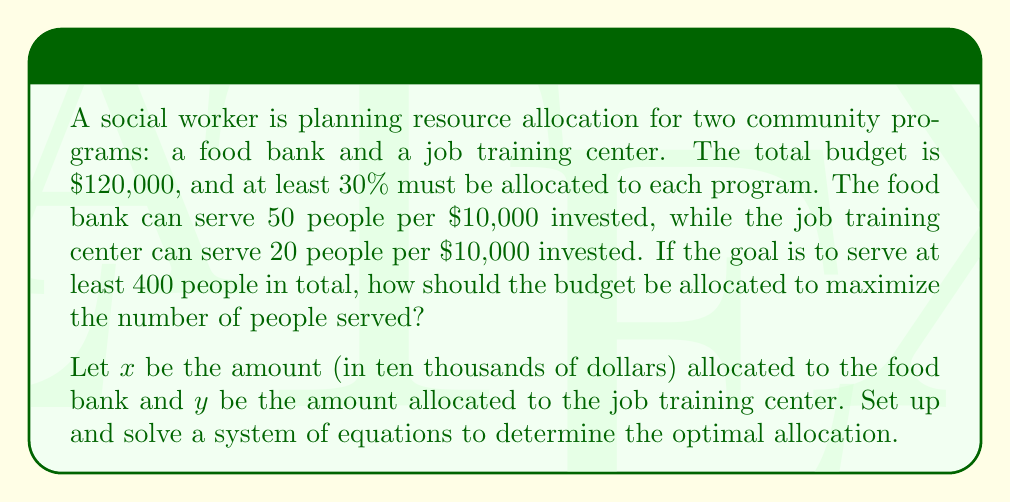Provide a solution to this math problem. Let's approach this step-by-step:

1) First, let's set up our constraints:

   Total budget: $x + y = 12$ (since the budget is $120,000)
   Minimum allocation: $x \geq 3.6$ and $y \geq 3.6$ (30% of $120,000 is $36,000)
   Minimum people served: $50x + 20y \geq 400$

2) Our objective is to maximize the number of people served, which is represented by $50x + 20y$.

3) Given the constraints, we can set up a system of equations:

   $$\begin{cases}
   x + y = 12 \\
   50x + 20y = 400 + z
   \end{cases}$$

   Where $z$ is the additional number of people served above the minimum 400.

4) Solving for $y$ in the first equation: $y = 12 - x$

5) Substituting this into the second equation:

   $50x + 20(12 - x) = 400 + z$
   $50x + 240 - 20x = 400 + z$
   $30x = 160 + z$
   $x = \frac{160 + z}{30}$

6) Since $y = 12 - x$, we can also express $y$ in terms of $z$:

   $y = 12 - \frac{160 + z}{30} = \frac{360 - 160 - z}{30} = \frac{200 - z}{30}$

7) Now, we need to ensure that both $x$ and $y$ are at least 3.6:

   $\frac{160 + z}{30} \geq 3.6$ and $\frac{200 - z}{30} \geq 3.6$

8) Solving these inequalities:

   $z \geq -52$ and $z \leq 92$

9) To maximize the number of people served, we want to maximize $z$ within these constraints. The maximum value for $z$ is 92.

10) Substituting $z = 92$ back into our equations for $x$ and $y$:

    $x = \frac{160 + 92}{30} = 8.4$
    $y = \frac{200 - 92}{30} = 3.6$

11) Therefore, the optimal allocation is $84,000 to the food bank and $36,000 to the job training center.

12) This allocation serves $50(8.4) + 20(3.6) = 492$ people in total.
Answer: $84,000 to food bank, $36,000 to job training center 